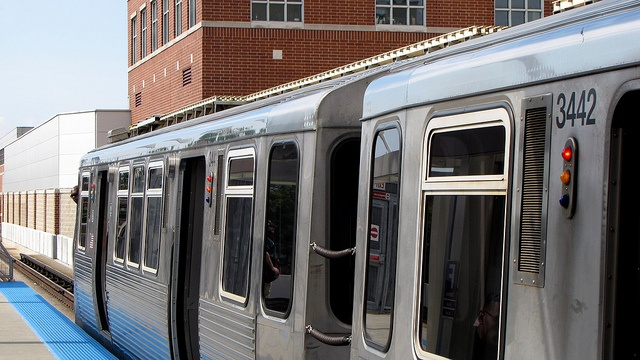Describe the objects in this image and their specific colors. I can see train in lavender, black, gray, darkgray, and lightgray tones and people in lavender, black, gray, and maroon tones in this image. 